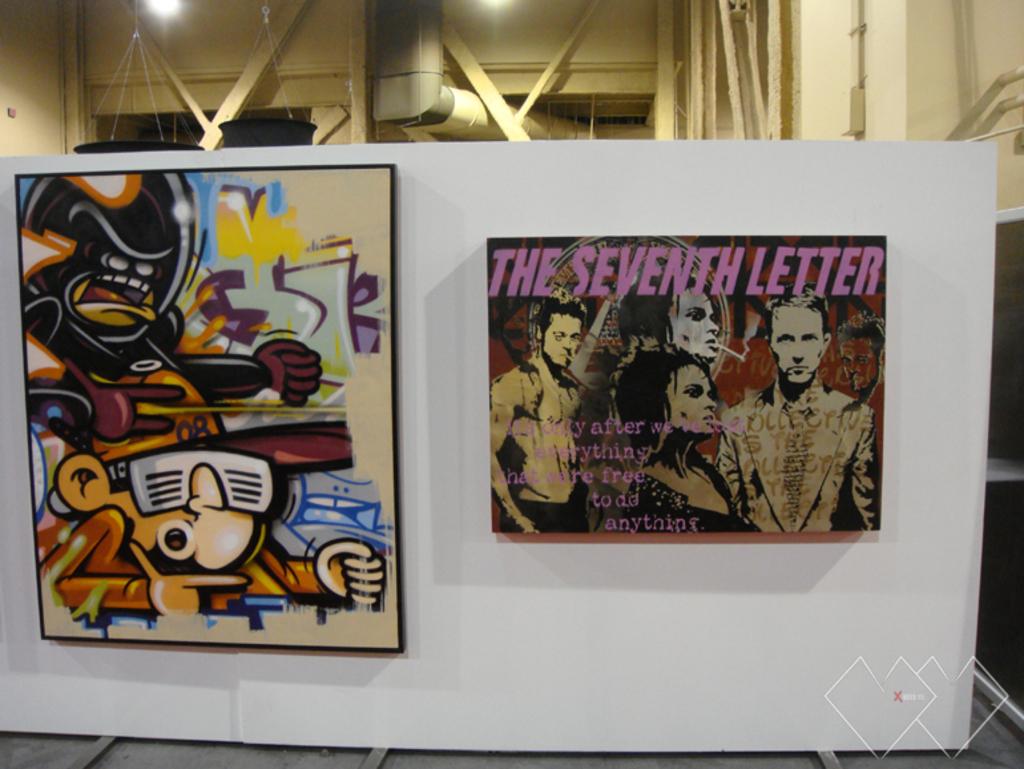The is the title of the picture on the right?
Your answer should be compact. The seventh letter. What letter in the alphabet comes after the title?
Provide a short and direct response. H. 